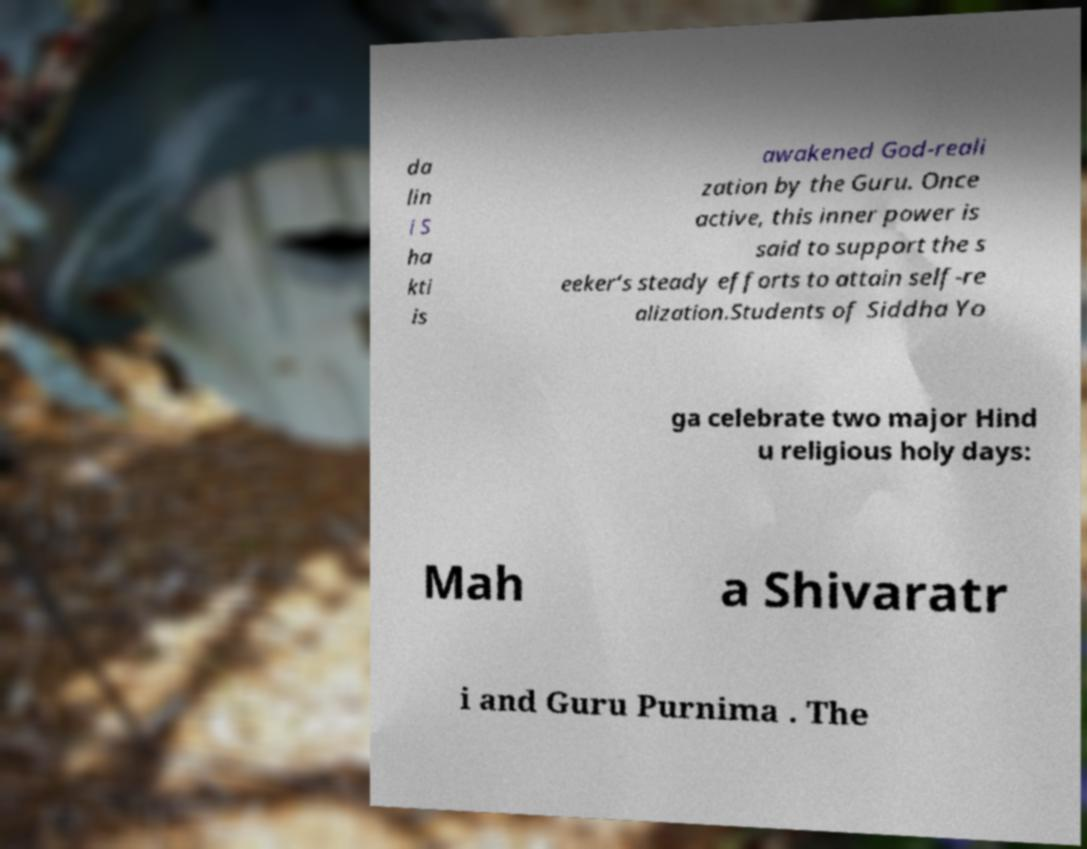I need the written content from this picture converted into text. Can you do that? da lin i S ha kti is awakened God-reali zation by the Guru. Once active, this inner power is said to support the s eeker’s steady efforts to attain self-re alization.Students of Siddha Yo ga celebrate two major Hind u religious holy days: Mah a Shivaratr i and Guru Purnima . The 